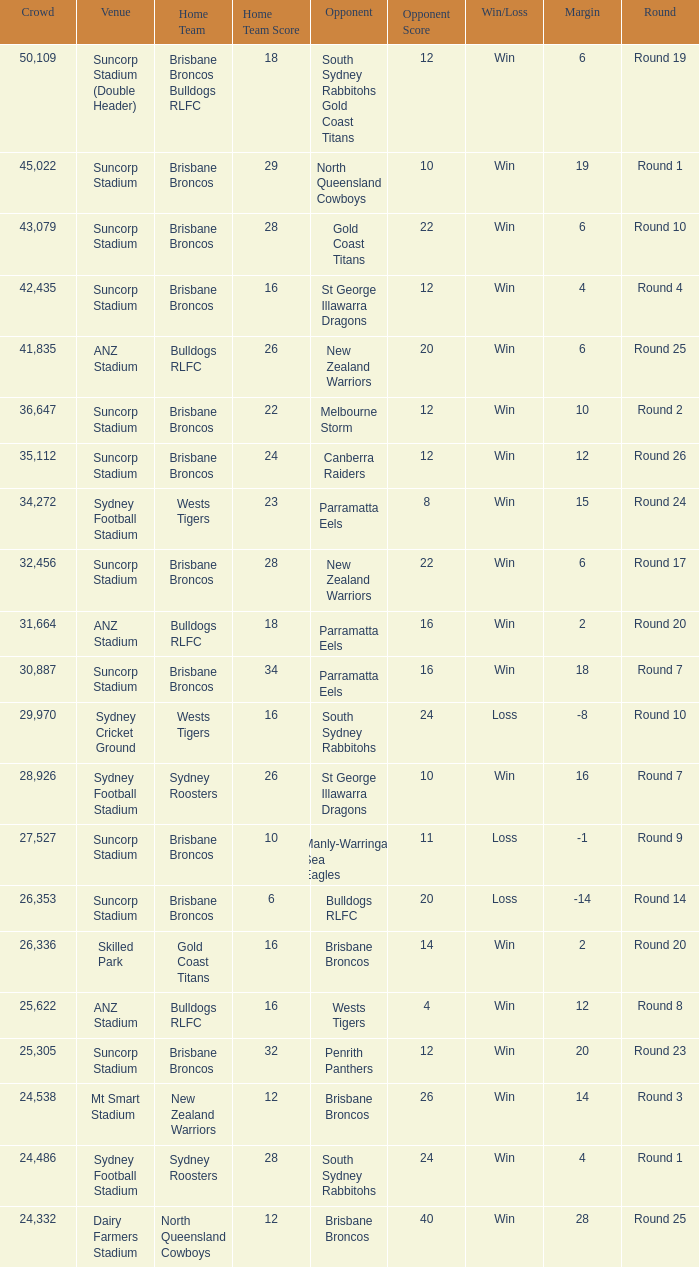What was the attendance at Round 9? 1.0. 